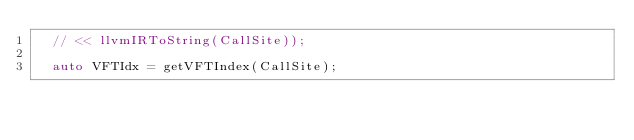Convert code to text. <code><loc_0><loc_0><loc_500><loc_500><_C++_>  // << llvmIRToString(CallSite));

  auto VFTIdx = getVFTIndex(CallSite);</code> 